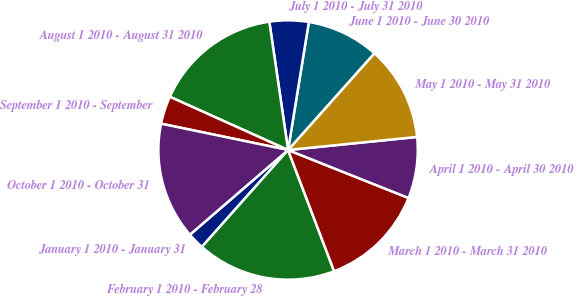Convert chart. <chart><loc_0><loc_0><loc_500><loc_500><pie_chart><fcel>January 1 2010 - January 31<fcel>February 1 2010 - February 28<fcel>March 1 2010 - March 31 2010<fcel>April 1 2010 - April 30 2010<fcel>May 1 2010 - May 31 2010<fcel>June 1 2010 - June 30 2010<fcel>July 1 2010 - July 31 2010<fcel>August 1 2010 - August 31 2010<fcel>September 1 2010 - September<fcel>October 1 2010 - October 31<nl><fcel>2.1%<fcel>17.35%<fcel>13.19%<fcel>7.64%<fcel>11.8%<fcel>9.03%<fcel>4.87%<fcel>15.96%<fcel>3.48%<fcel>14.58%<nl></chart> 